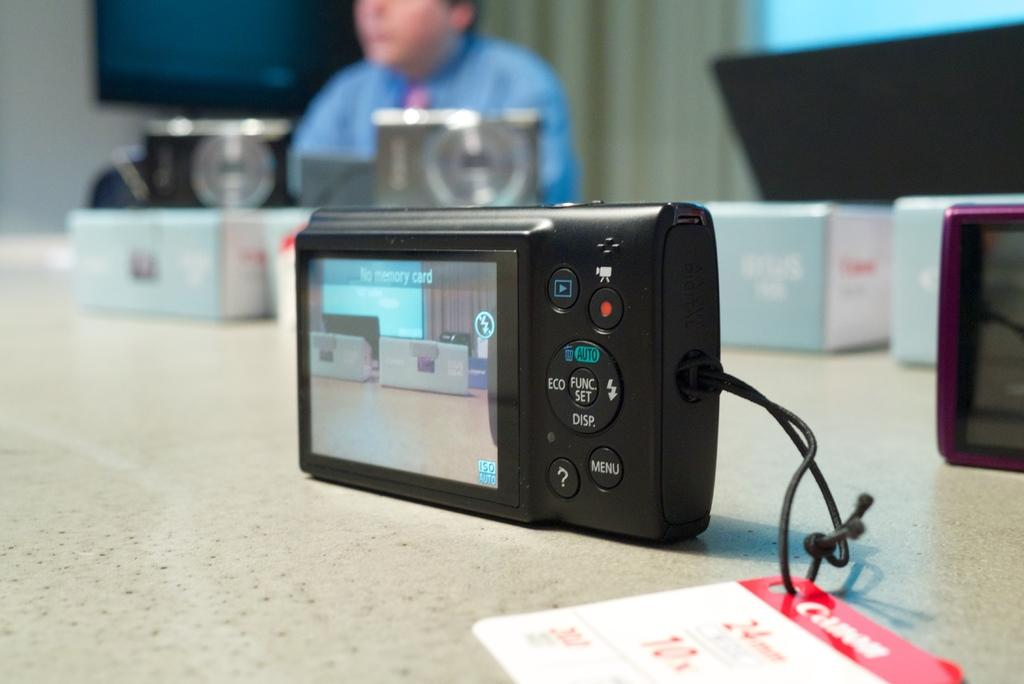What piece of furniture is in the image? There is a table in the image. What electronic device is on the table? A camera is present on the table. What else can be seen on the table besides the camera? There are other objects on the table. Can you describe the person in the image? There is a person sitting at the back of the image. What is on the wall in the image? There is a TV on the wall. What is beside the TV on the wall? There is a curtain beside the TV. What type of stocking is hanging from the camera in the image? There is no stocking hanging from the camera in the image. How does the person in the image use the comb? There is no comb present in the image. 